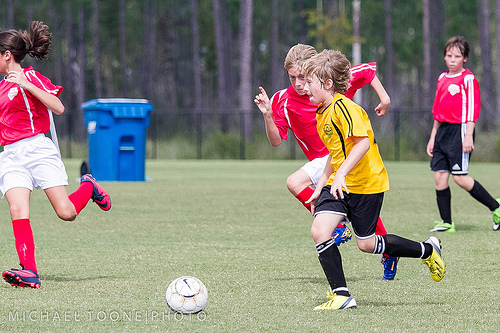<image>
Is there a boy behind the boy? Yes. From this viewpoint, the boy is positioned behind the boy, with the boy partially or fully occluding the boy. 